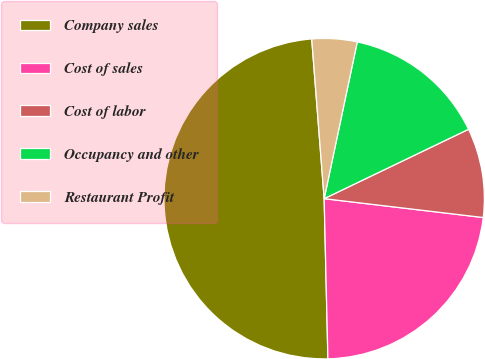Convert chart. <chart><loc_0><loc_0><loc_500><loc_500><pie_chart><fcel>Company sales<fcel>Cost of sales<fcel>Cost of labor<fcel>Occupancy and other<fcel>Restaurant Profit<nl><fcel>49.14%<fcel>22.75%<fcel>9.01%<fcel>14.56%<fcel>4.55%<nl></chart> 